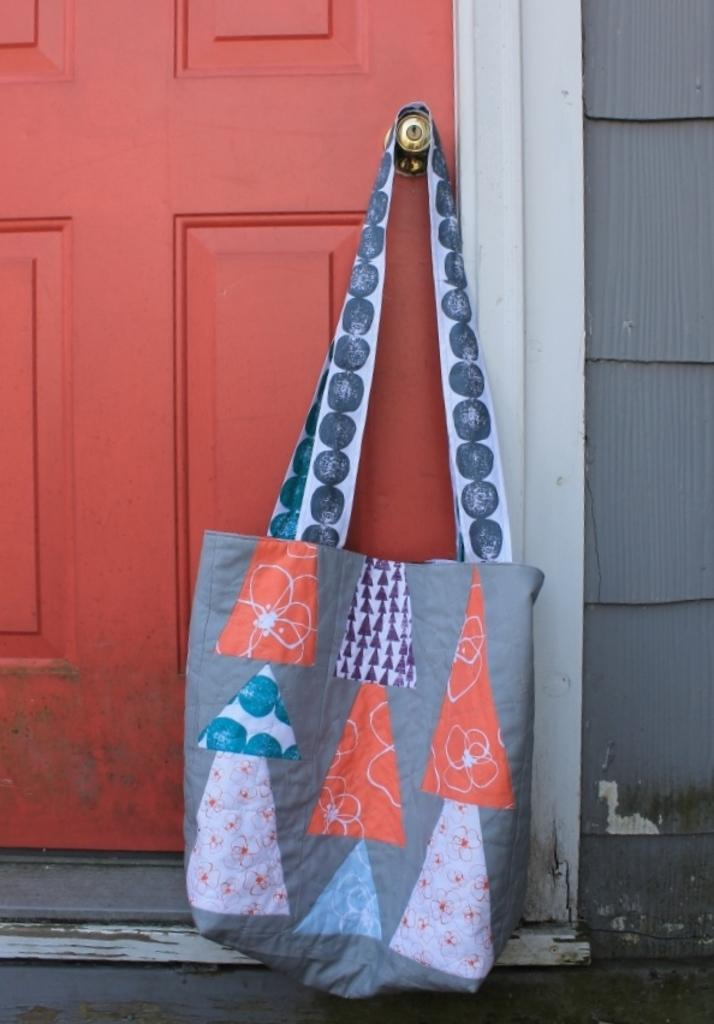What is the main object in the image? There is a door in the image. What is hanging on the door? A gray, white, and orange bag is hanged on the door. What can be seen on the right side of the image? There is a wall on the right side of the image. Who is the owner of the quince in the image? There is no quince present in the image. Can you tell me how many mittens are visible in the image? There are no mittens present in the image. 